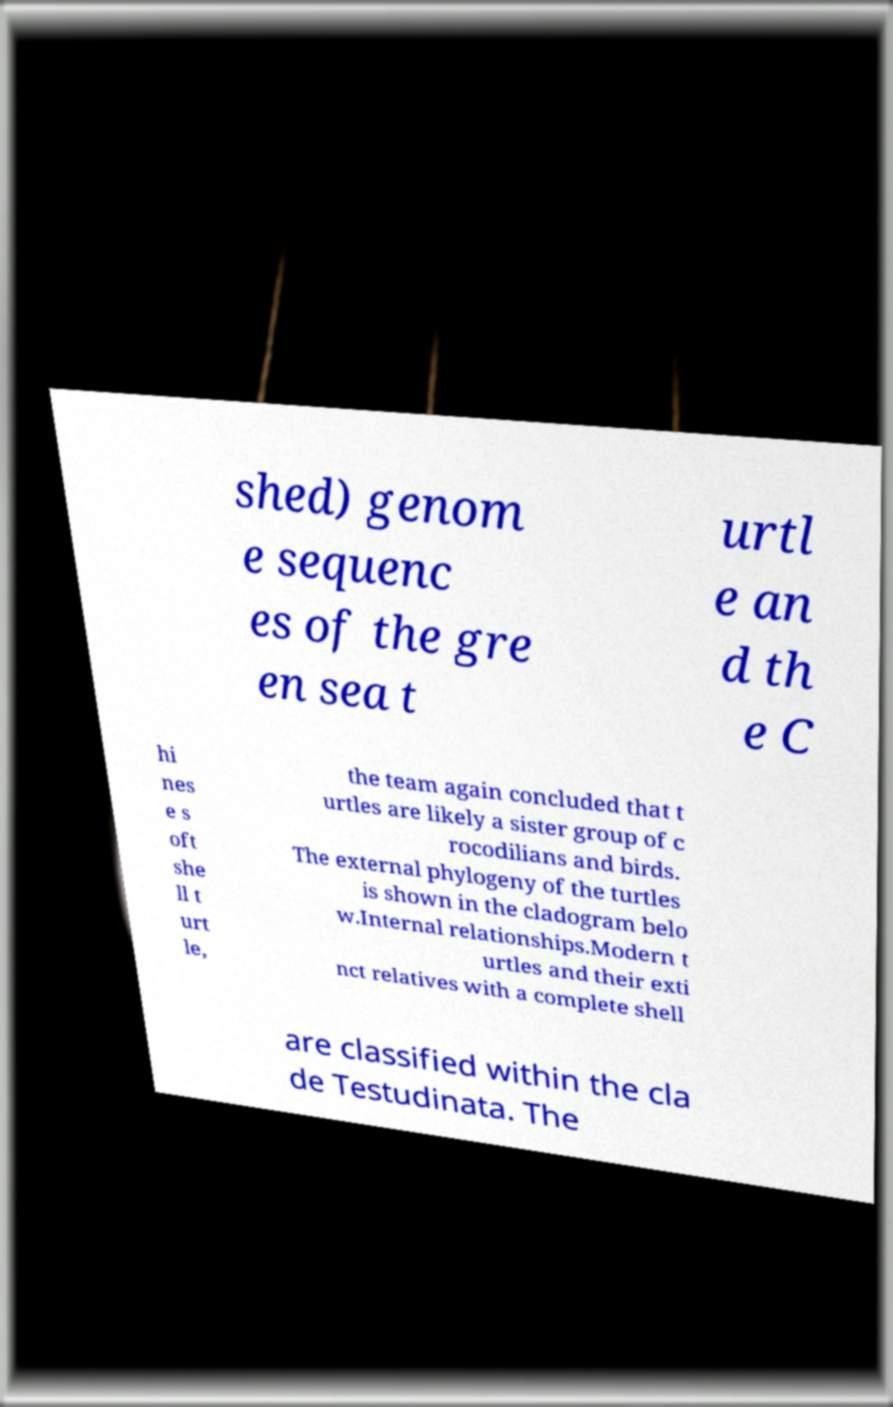There's text embedded in this image that I need extracted. Can you transcribe it verbatim? shed) genom e sequenc es of the gre en sea t urtl e an d th e C hi nes e s oft she ll t urt le, the team again concluded that t urtles are likely a sister group of c rocodilians and birds. The external phylogeny of the turtles is shown in the cladogram belo w.Internal relationships.Modern t urtles and their exti nct relatives with a complete shell are classified within the cla de Testudinata. The 